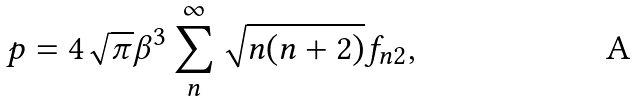Convert formula to latex. <formula><loc_0><loc_0><loc_500><loc_500>p = 4 \sqrt { \pi } \beta ^ { 3 } \sum _ { n } ^ { \infty } \sqrt { n ( n + 2 ) } f _ { n 2 } ,</formula> 